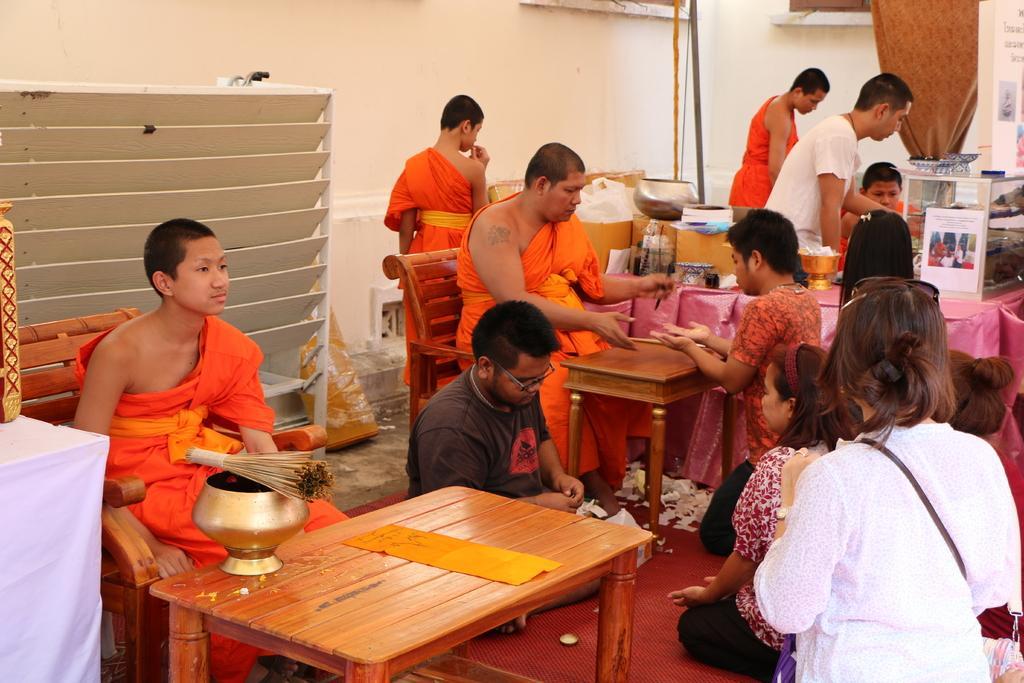In one or two sentences, can you explain what this image depicts? There are group of saints sitting in chair and there is a table and group of people in front of them. 